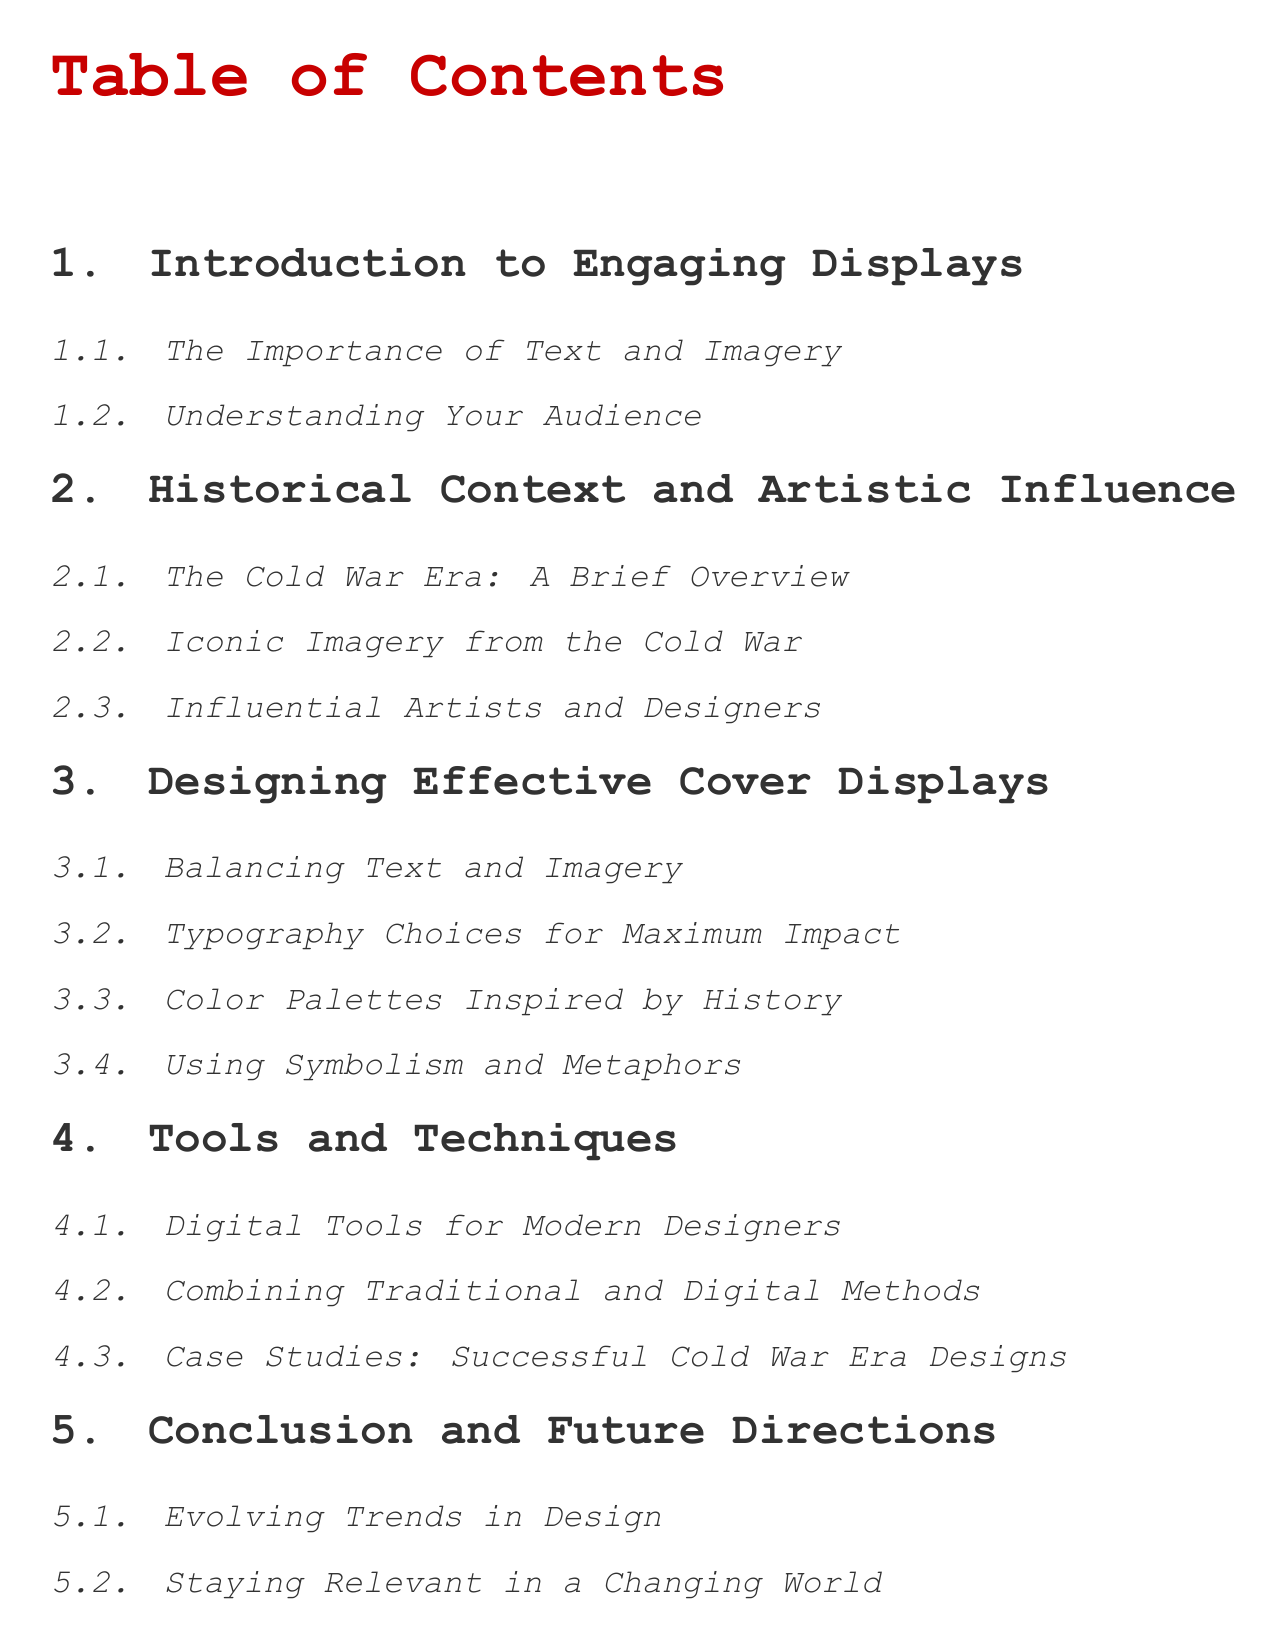What is the first section in the document? The first section is "Introduction to Engaging Displays."
Answer: Introduction to Engaging Displays Who are the influential figures discussed in the historical context section? The section discusses "Influential Artists and Designers."
Answer: Influential Artists and Designers What design element is emphasized in the third section? The third section emphasizes "Balancing Text and Imagery."
Answer: Balancing Text and Imagery Which color palette theme is mentioned in the design section? The design section mentions "Color Palettes Inspired by History."
Answer: Color Palettes Inspired by History What tools are discussed for modern designers? The subsection discusses "Digital Tools for Modern Designers."
Answer: Digital Tools for Modern Designers How many subsections are in the "Historical Context and Artistic Influence" section? The section has three subsections: "The Cold War Era: A Brief Overview," "Iconic Imagery from the Cold War," and "Influential Artists and Designers."
Answer: Three What future topic is explored in the conclusion section? The conclusion section explores "Evolving Trends in Design."
Answer: Evolving Trends in Design What type of methods does the tools section discuss? The subsection discusses "Combining Traditional and Digital Methods."
Answer: Combining Traditional and Digital Methods 